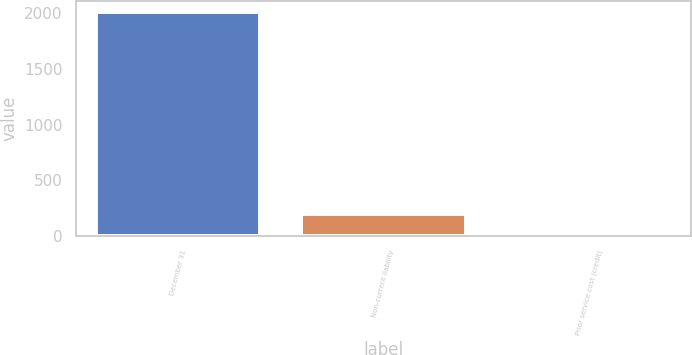Convert chart. <chart><loc_0><loc_0><loc_500><loc_500><bar_chart><fcel>December 31<fcel>Non-current liability<fcel>Prior service cost (credit)<nl><fcel>2007<fcel>201.42<fcel>0.8<nl></chart> 